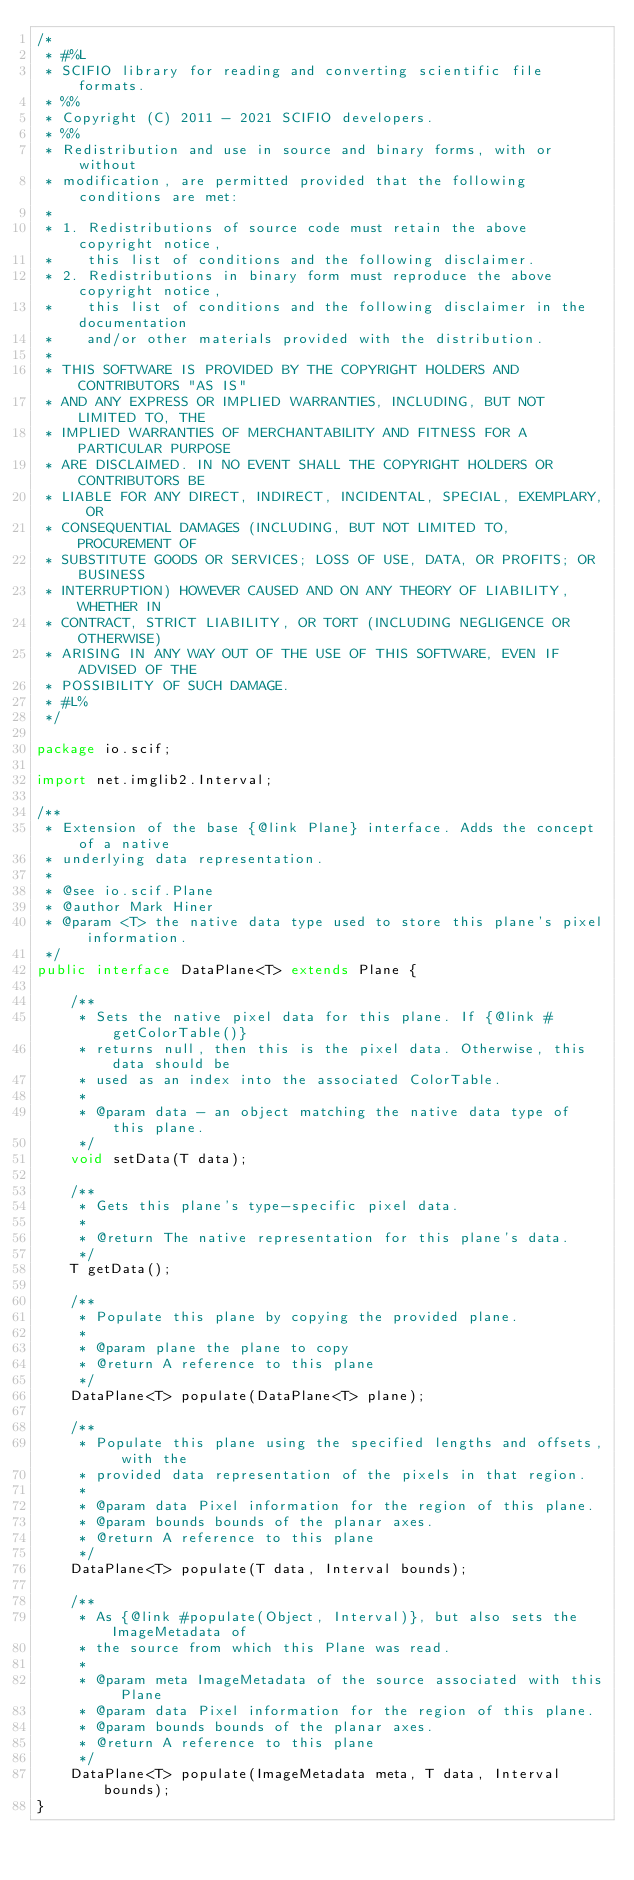Convert code to text. <code><loc_0><loc_0><loc_500><loc_500><_Java_>/*
 * #%L
 * SCIFIO library for reading and converting scientific file formats.
 * %%
 * Copyright (C) 2011 - 2021 SCIFIO developers.
 * %%
 * Redistribution and use in source and binary forms, with or without
 * modification, are permitted provided that the following conditions are met:
 * 
 * 1. Redistributions of source code must retain the above copyright notice,
 *    this list of conditions and the following disclaimer.
 * 2. Redistributions in binary form must reproduce the above copyright notice,
 *    this list of conditions and the following disclaimer in the documentation
 *    and/or other materials provided with the distribution.
 * 
 * THIS SOFTWARE IS PROVIDED BY THE COPYRIGHT HOLDERS AND CONTRIBUTORS "AS IS"
 * AND ANY EXPRESS OR IMPLIED WARRANTIES, INCLUDING, BUT NOT LIMITED TO, THE
 * IMPLIED WARRANTIES OF MERCHANTABILITY AND FITNESS FOR A PARTICULAR PURPOSE
 * ARE DISCLAIMED. IN NO EVENT SHALL THE COPYRIGHT HOLDERS OR CONTRIBUTORS BE
 * LIABLE FOR ANY DIRECT, INDIRECT, INCIDENTAL, SPECIAL, EXEMPLARY, OR
 * CONSEQUENTIAL DAMAGES (INCLUDING, BUT NOT LIMITED TO, PROCUREMENT OF
 * SUBSTITUTE GOODS OR SERVICES; LOSS OF USE, DATA, OR PROFITS; OR BUSINESS
 * INTERRUPTION) HOWEVER CAUSED AND ON ANY THEORY OF LIABILITY, WHETHER IN
 * CONTRACT, STRICT LIABILITY, OR TORT (INCLUDING NEGLIGENCE OR OTHERWISE)
 * ARISING IN ANY WAY OUT OF THE USE OF THIS SOFTWARE, EVEN IF ADVISED OF THE
 * POSSIBILITY OF SUCH DAMAGE.
 * #L%
 */

package io.scif;

import net.imglib2.Interval;

/**
 * Extension of the base {@link Plane} interface. Adds the concept of a native
 * underlying data representation.
 *
 * @see io.scif.Plane
 * @author Mark Hiner
 * @param <T> the native data type used to store this plane's pixel information.
 */
public interface DataPlane<T> extends Plane {

	/**
	 * Sets the native pixel data for this plane. If {@link #getColorTable()}
	 * returns null, then this is the pixel data. Otherwise, this data should be
	 * used as an index into the associated ColorTable.
	 *
	 * @param data - an object matching the native data type of this plane.
	 */
	void setData(T data);

	/**
	 * Gets this plane's type-specific pixel data.
	 *
	 * @return The native representation for this plane's data.
	 */
	T getData();

	/**
	 * Populate this plane by copying the provided plane.
	 *
	 * @param plane the plane to copy
	 * @return A reference to this plane
	 */
	DataPlane<T> populate(DataPlane<T> plane);

	/**
	 * Populate this plane using the specified lengths and offsets, with the
	 * provided data representation of the pixels in that region.
	 *
	 * @param data Pixel information for the region of this plane.
	 * @param bounds bounds of the planar axes.
	 * @return A reference to this plane
	 */
	DataPlane<T> populate(T data, Interval bounds);

	/**
	 * As {@link #populate(Object, Interval)}, but also sets the ImageMetadata of
	 * the source from which this Plane was read.
	 *
	 * @param meta ImageMetadata of the source associated with this Plane
	 * @param data Pixel information for the region of this plane.
	 * @param bounds bounds of the planar axes.
	 * @return A reference to this plane
	 */
	DataPlane<T> populate(ImageMetadata meta, T data, Interval bounds);
}
</code> 